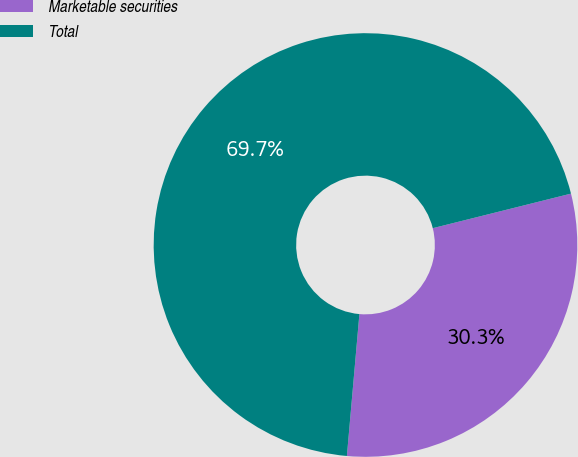<chart> <loc_0><loc_0><loc_500><loc_500><pie_chart><fcel>Marketable securities<fcel>Total<nl><fcel>30.3%<fcel>69.7%<nl></chart> 